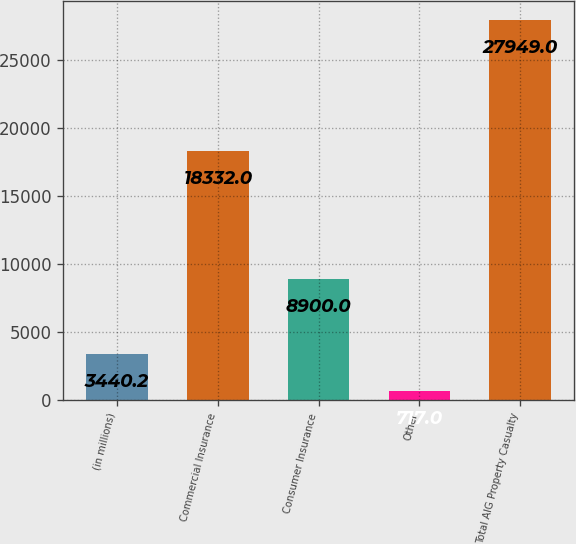Convert chart to OTSL. <chart><loc_0><loc_0><loc_500><loc_500><bar_chart><fcel>(in millions)<fcel>Commercial Insurance<fcel>Consumer Insurance<fcel>Other<fcel>Total AIG Property Casualty<nl><fcel>3440.2<fcel>18332<fcel>8900<fcel>717<fcel>27949<nl></chart> 